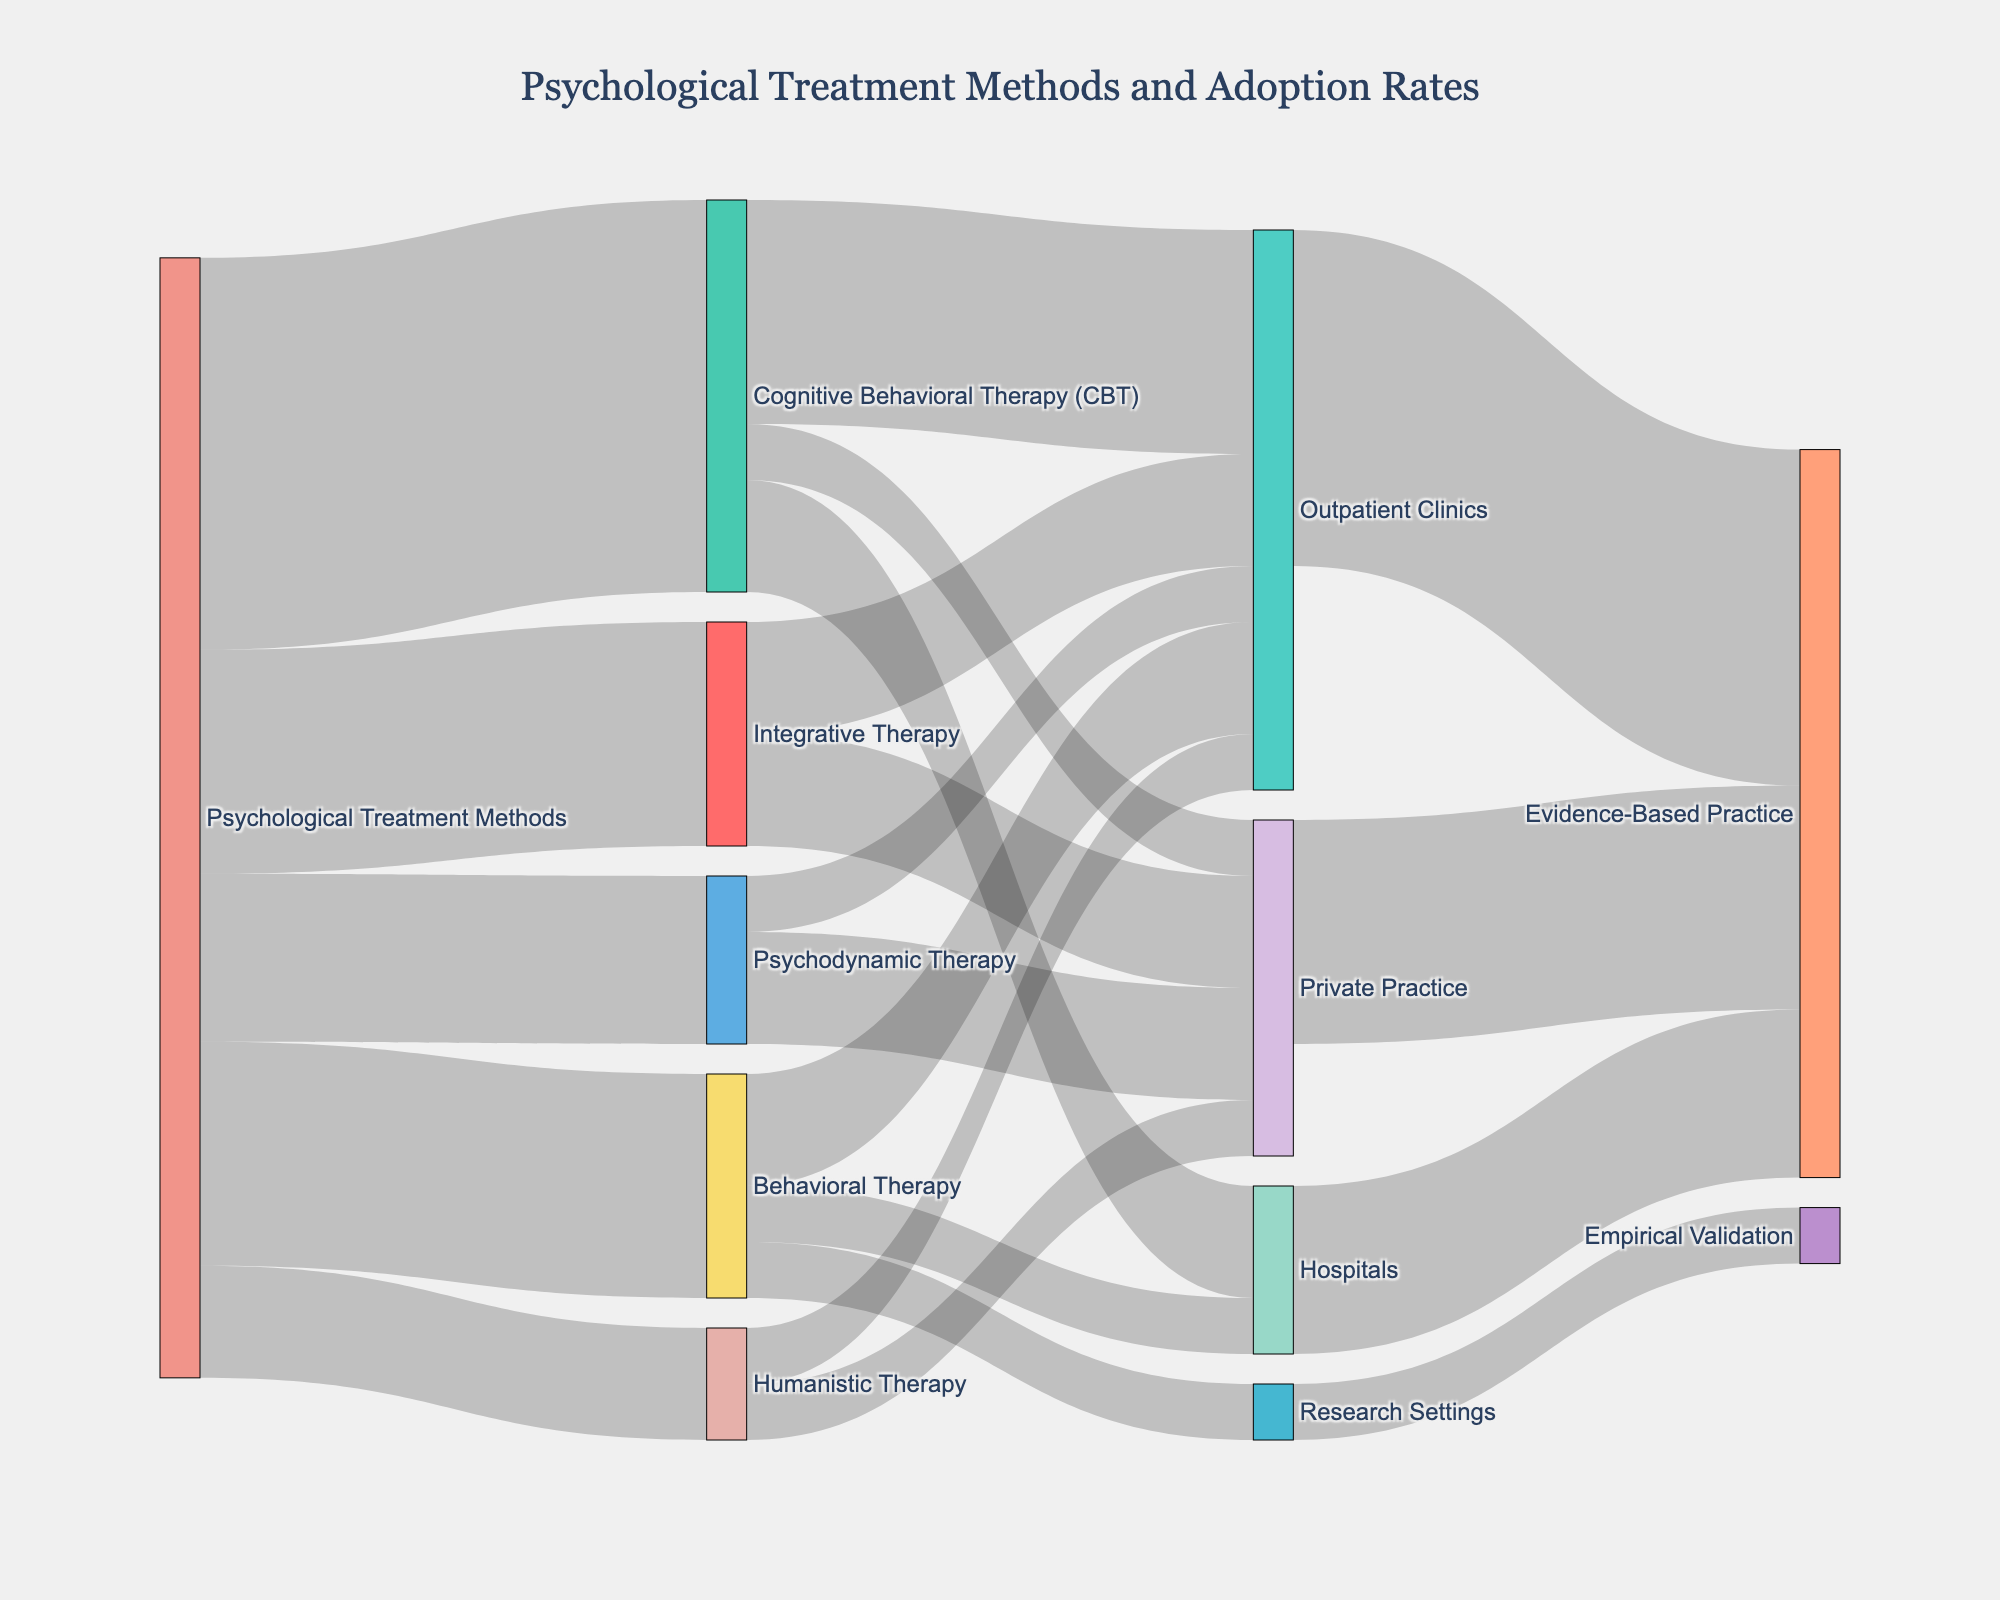what is the title of the diagram? The title is usually located at the top center of the diagram and summarizes what the diagram represents. Here, it reads "Psychological Treatment Methods and Adoption Rates."
Answer: Psychological Treatment Methods and Adoption Rates Which treatment method has the highest adoption rate? By examining the thickness and value of the flow lines from the "Psychological Treatment Methods" node, Cognitive Behavioral Therapy (CBT) has the highest value at 35.
Answer: Cognitive Behavioral Therapy (CBT) How many treatment methods lead to outpatient clinics? The connection lines indicate the flow from treatment methods to clinic settings. Outpatient clinics receive flows from four treatment methods: Cognitive Behavioral Therapy (CBT), Psychodynamic Therapy, Humanistic Therapy, and Integrative Therapy.
Answer: Four Compare the adoption rates of Behavioral Therapy and Humanistic Therapy. Which one is greater? By analyzing the values of the links branching from the "Psychological Treatment Methods" node, Behavioral Therapy has a value of 20 while Humanistic Therapy has a value of 10. Therefore, Behavioral Therapy has a higher adoption rate.
Answer: Behavioral Therapy How much of Cognitive Behavioral Therapy (CBT) is adopted in hospitals? The flow from Cognitive Behavioral Therapy to hospitals shows a value of 10.
Answer: 10 What is the total value flowing into Evidence-Based Practice? Add up the values connected to the "Evidence-Based Practice" node: Outpatient Clinics (30), Hospitals (15), and Private Practice (20). The total is 30 + 15 + 20 = 65.
Answer: 65 Which clinical setting adopts Integrative Therapy the least? By looking at the flows from Integrative Therapy, both Outpatient Clinics and Private Practice have equal adoption rates of 10. Since no other settings are shown, there is no single setting with the least adoption rate; they are equal.
Answer: Outpatient Clinics and Private Practice equally Identify one method with equal adoption rates across all its clinical settings. By examining the flows from each treatment method, Humanistic Therapy flows equally to Outpatient Clinics and Private Practice, both at a value of 5.
Answer: Humanistic Therapy Can you determine the exact percentage of Research Settings' contribution to Empirical Validation? The flow value from Research Settings to Empirical Validation is 5. The total value flowing into Evidence-Based Practice and Empirical Validation combined is 70. Hence, the percentage is (5/70) * 100 ≈ 7.14%.
Answer: 7.14% 